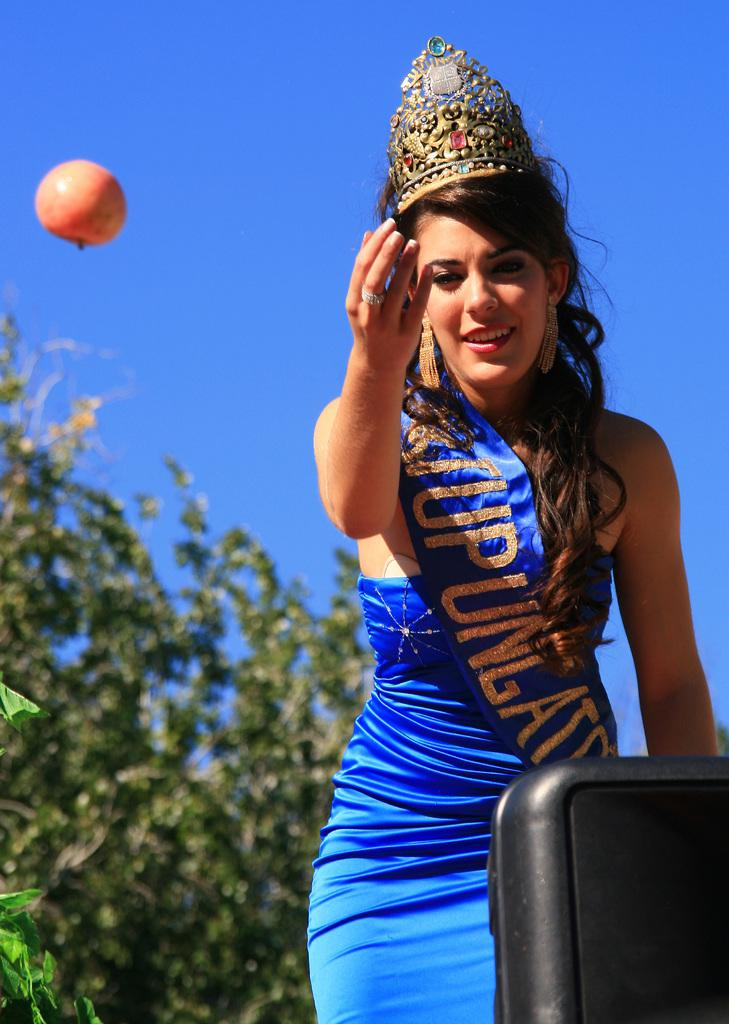Who is present in the image? There is a woman in the image. What is the woman wearing? The woman is wearing a blue dress. What accessory is the woman wearing on her head? The woman is wearing a crown on her head. What can be seen behind the woman? There is a tree behind the woman. What is the color of the sky in the image? The sky is blue in color. What is visible in the air near the woman? There is a fruit visible in the air. How many balls are visible in the image? There are no balls visible in the image. What type of property does the woman own in the image? There is no information about the woman owning any property in the image. 